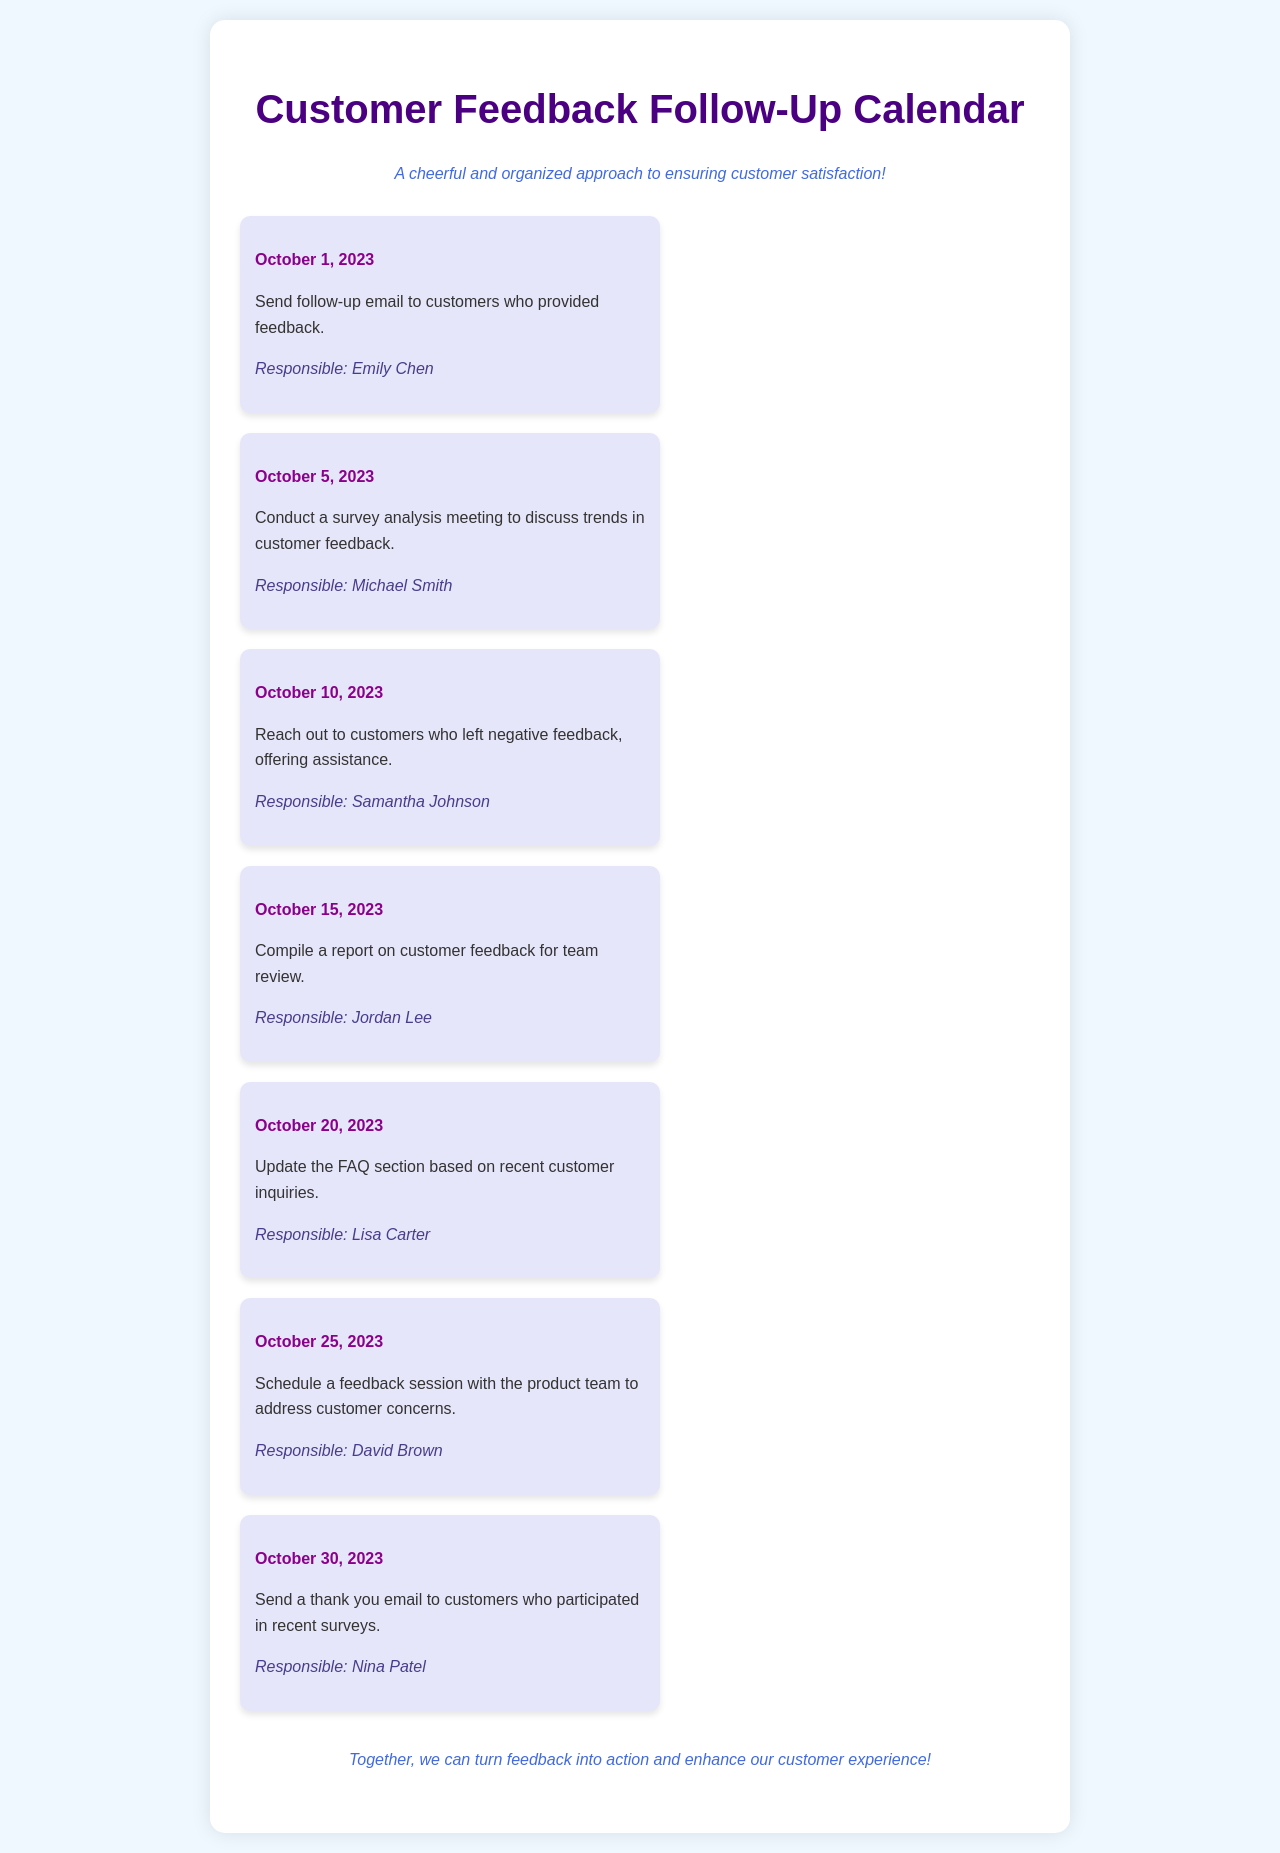What is the first follow-up action scheduled? The first follow-up action is to send a follow-up email to customers who provided feedback, scheduled for October 1, 2023.
Answer: Send follow-up email to customers who provided feedback Who is responsible for the survey analysis meeting? The survey analysis meeting is scheduled for October 5, 2023, and is responsibility of Michael Smith.
Answer: Michael Smith What action is scheduled for October 20, 2023? On October 20, 2023, the action scheduled is to update the FAQ section based on recent customer inquiries.
Answer: Update the FAQ section How many days are there between the first and last scheduled actions? The first action is on October 1, 2023, and the last action is on October 30, 2023, resulting in a span of 29 days.
Answer: 29 days Who is scheduled to reach out to customers who left negative feedback? The action to reach out to customers who left negative feedback is assigned to Samantha Johnson.
Answer: Samantha Johnson What do we aim to achieve with these follow-up actions? The document emphasizes enhancing customer satisfaction and addressing feedback through organized actions.
Answer: Enhance customer experience Which action involves a report compilation? The action involving compiling a report on customer feedback is scheduled for October 15, 2023.
Answer: Compile a report on customer feedback How many total follow-up actions are outlined in the calendar? There are a total of seven follow-up actions outlined in the calendar.
Answer: Seven actions 